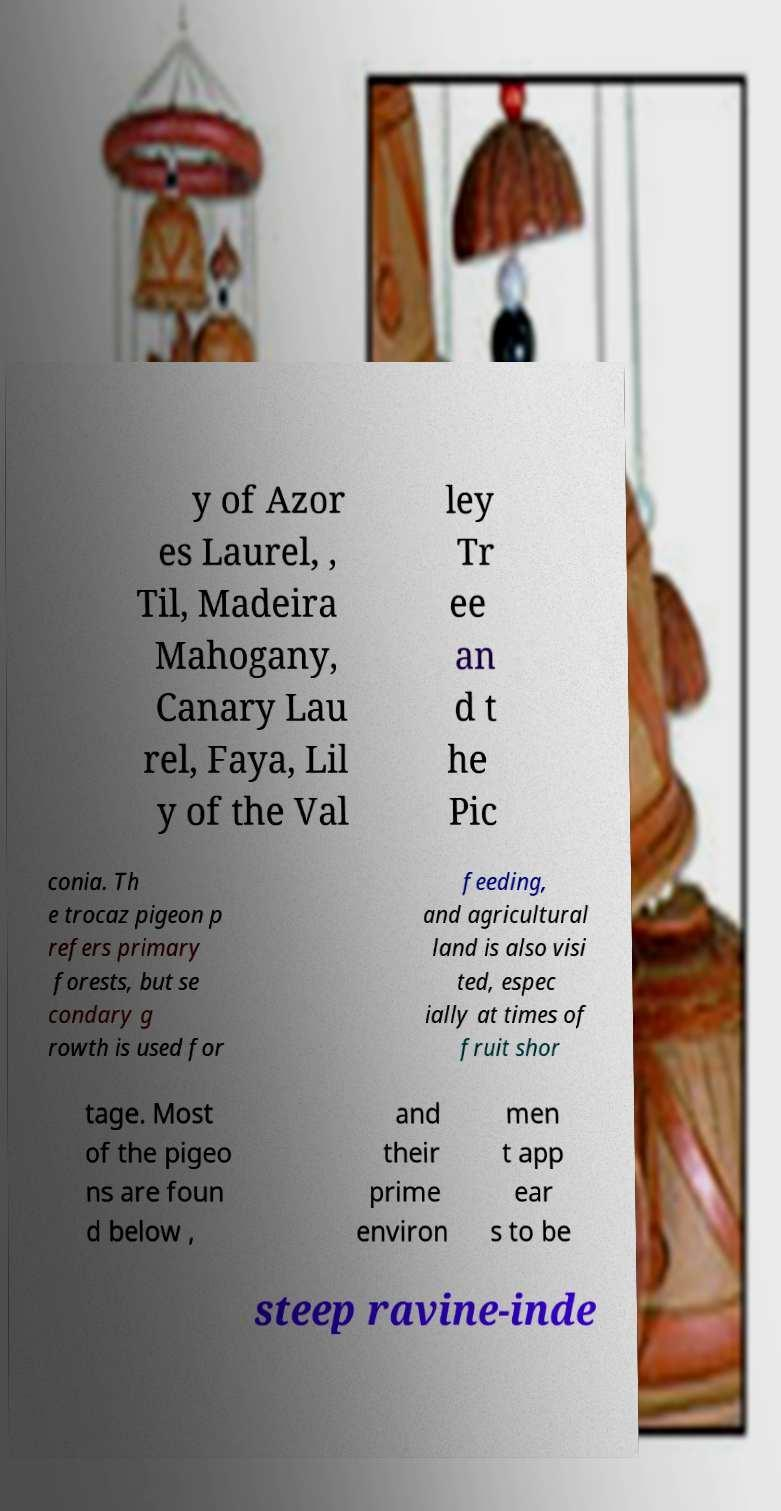Can you read and provide the text displayed in the image?This photo seems to have some interesting text. Can you extract and type it out for me? y of Azor es Laurel, , Til, Madeira Mahogany, Canary Lau rel, Faya, Lil y of the Val ley Tr ee an d t he Pic conia. Th e trocaz pigeon p refers primary forests, but se condary g rowth is used for feeding, and agricultural land is also visi ted, espec ially at times of fruit shor tage. Most of the pigeo ns are foun d below , and their prime environ men t app ear s to be steep ravine-inde 